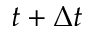<formula> <loc_0><loc_0><loc_500><loc_500>t + \Delta t</formula> 